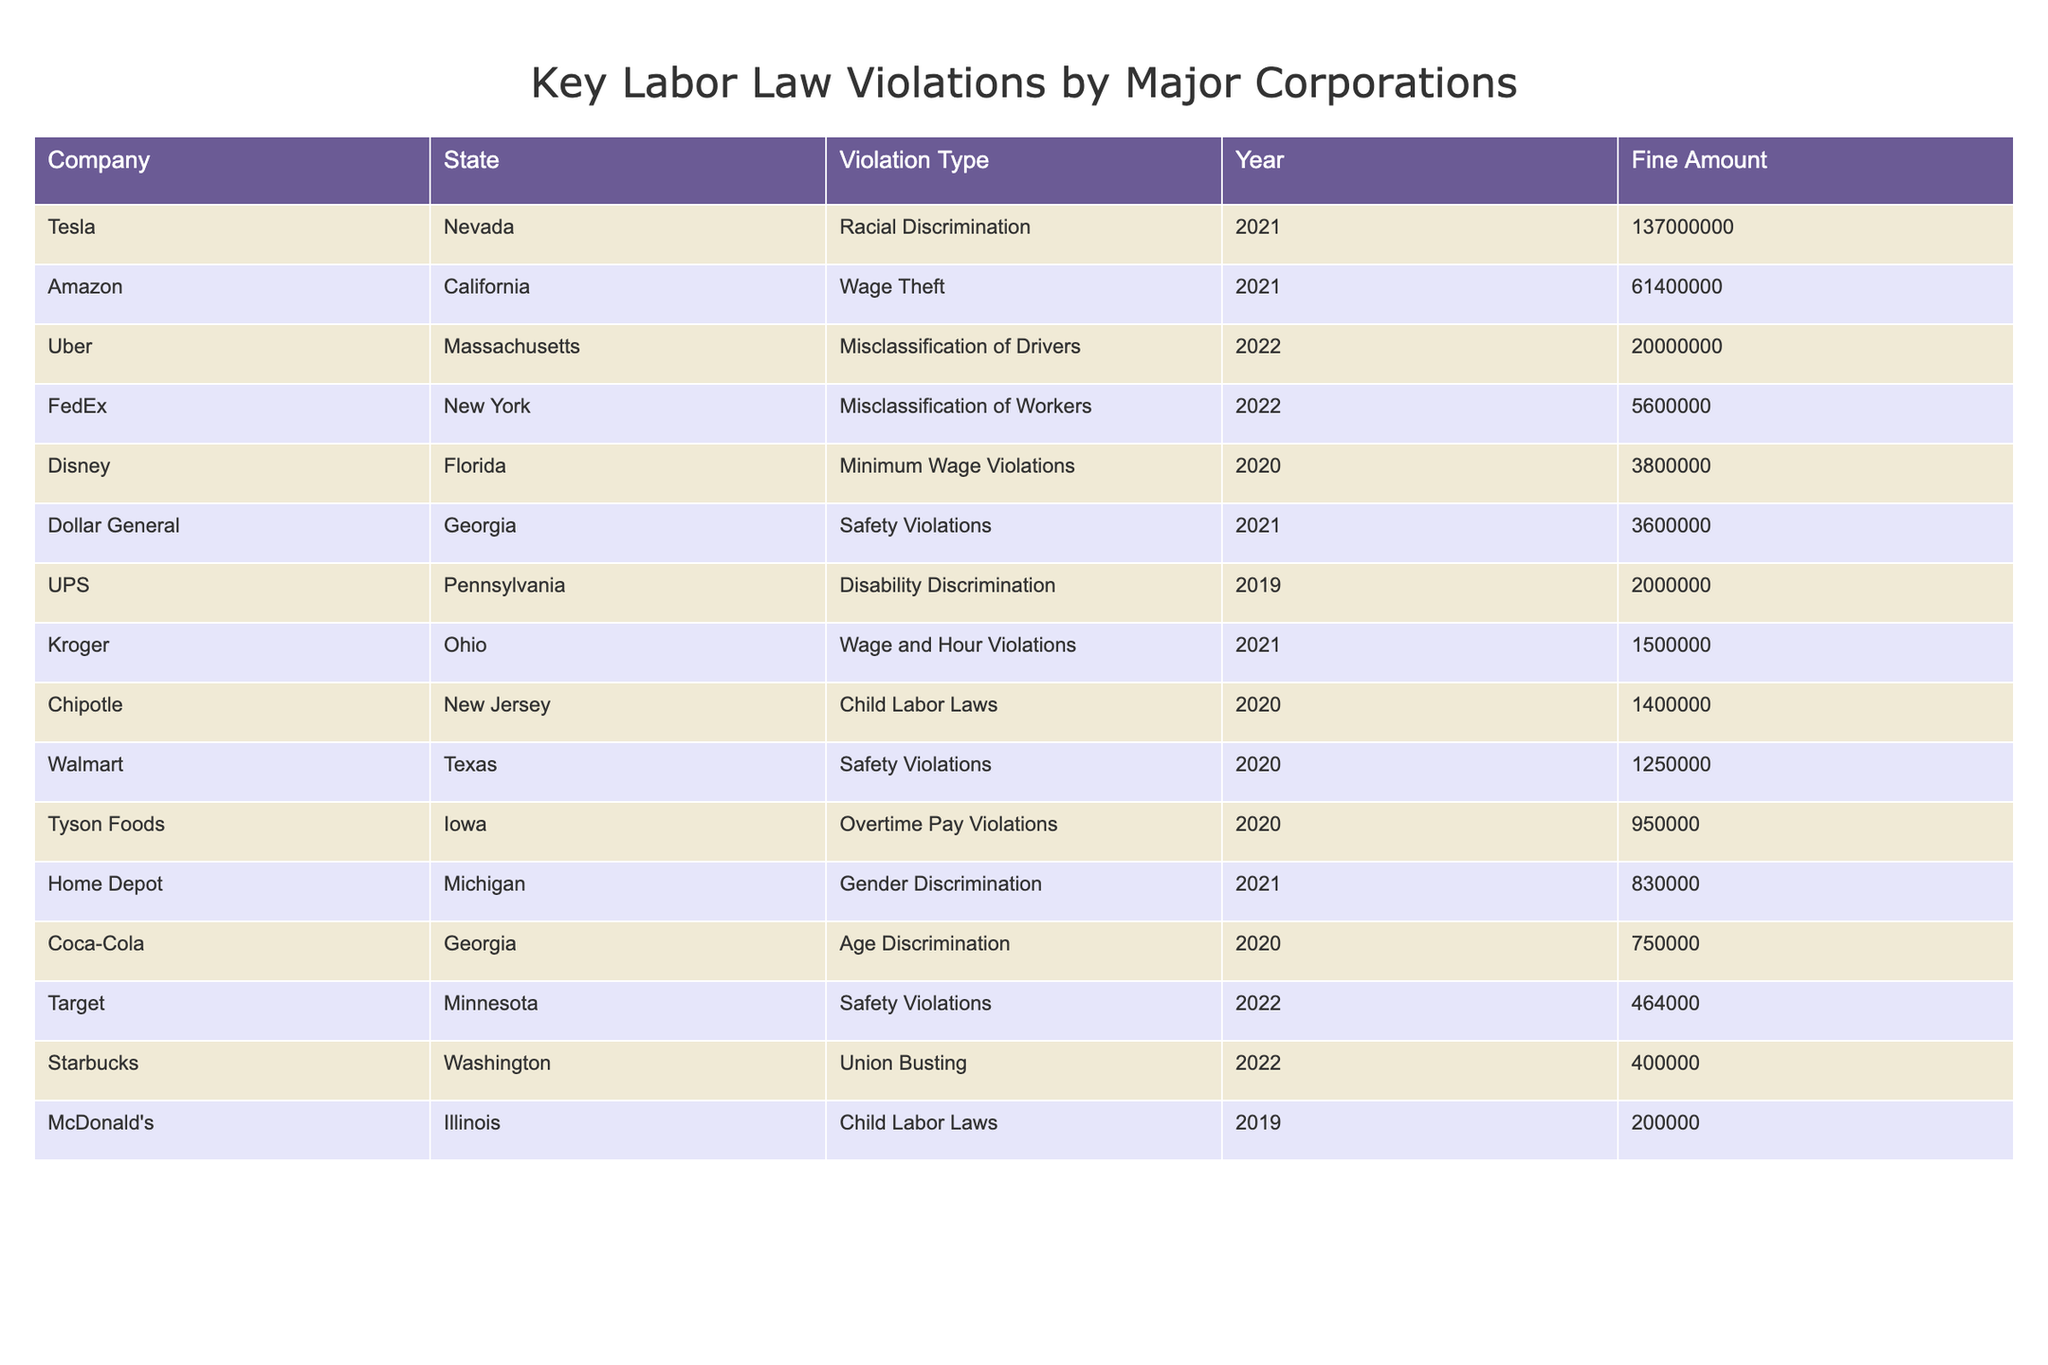What is the highest fine amount listed in the table? The highest fine amount can be found by examining the "Fine Amount" column. After reviewing the values, the highest amount is for Tesla in Nevada, which is $137,000,000.
Answer: 137000000 Which company was fined for Child Labor Laws and in what state? To find this, look at the "Violation Type" column for "Child Labor Laws." The company is McDonald's and it is in Illinois.
Answer: McDonald's, Illinois How many safety violations are recorded in total, based on the table? Count the rows under "Violation Type" where the entry is "Safety Violations." There are three entries: Walmart in Texas, Dollar General in Georgia, and Target in Minnesota. Therefore, the total is 3 safety violations.
Answer: 3 Is there any company listed that has faced a violation related to union busting? Check the "Violation Type" column for "Union Busting." Yes, Starbucks in Washington faced a violation related to union busting.
Answer: Yes What is the combined fine amount for all companies listed in Georgia? First, identify the companies in Georgia, which are Dollar General and Coca-Cola, along with their fines of $3,600,000 and $750,000, respectively. Sum these values: $3,600,000 + $750,000 = $4,350,000.
Answer: 4350000 In which year did FedEx receive a fine and what was the fine amount? Look at the row for FedEx and read the "Year" and "Fine Amount" columns. FedEx received a fine in 2022, and the amount was $5,600,000.
Answer: 2022, 5600000 Which state had the most companies listed for labor law violations? By analyzing the table, we find that Georgia has two entries: Dollar General and Coca-Cola, while other states have either one or none. Therefore, Georgia has the most companies listed for violations.
Answer: Georgia What is the average fine amount for companies that faced Wage Theft violations? Identify the companies with "Wage Theft" violations, which is Amazon in California with a fine of $61,400,000. Since there's only one entry, the average is $61,400,000.
Answer: 61400000 Which company faced the largest fine for Racial Discrimination, and what was the fine? Search for "Racial Discrimination" under "Violation Type." The only entry is Tesla in Nevada with a fine amount of $137,000,000, which is also the largest fine.
Answer: Tesla, 137000000 How many companies had fines exceeding $10 million? Examine the "Fine Amount" column for values over $10 million. The companies are Amazon ($61,400,000), Tesla ($137,000,000), and Uber ($20,000,000). Therefore, there are three companies.
Answer: 3 